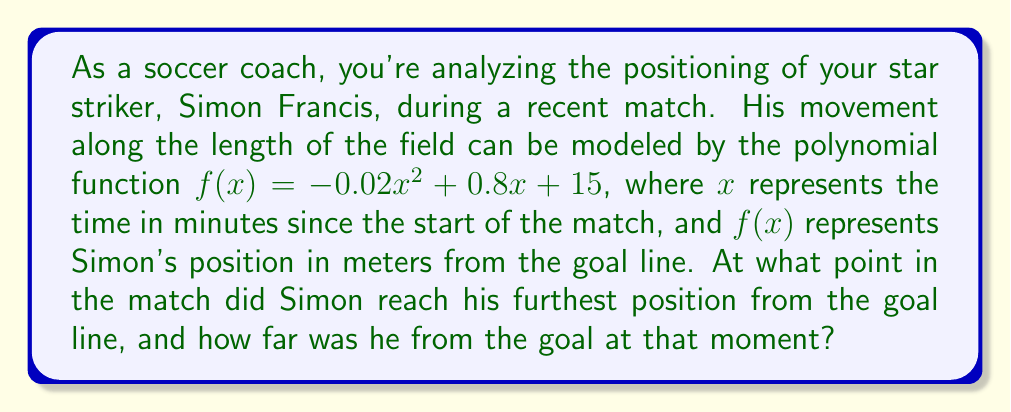Can you solve this math problem? To solve this problem, we need to follow these steps:

1) The function $f(x) = -0.02x^2 + 0.8x + 15$ is a quadratic function, which forms a parabola when graphed. Since the coefficient of $x^2$ is negative (-0.02), this parabola opens downward and has a maximum point.

2) The maximum point of a parabola occurs at the vertex. For a quadratic function in the form $f(x) = ax^2 + bx + c$, the x-coordinate of the vertex is given by $x = -\frac{b}{2a}$.

3) In our case, $a = -0.02$ and $b = 0.8$. Let's calculate the x-coordinate of the vertex:

   $x = -\frac{b}{2a} = -\frac{0.8}{2(-0.02)} = -\frac{0.8}{-0.04} = 20$

4) This means Simon reached his furthest position from the goal line 20 minutes into the match.

5) To find how far he was from the goal at that moment, we need to calculate $f(20)$:

   $f(20) = -0.02(20)^2 + 0.8(20) + 15$
          $= -0.02(400) + 16 + 15$
          $= -8 + 16 + 15$
          $= 23$

Therefore, Simon was 23 meters from the goal line at his furthest position.
Answer: Simon Francis reached his furthest position from the goal line 20 minutes into the match, at which point he was 23 meters from the goal line. 